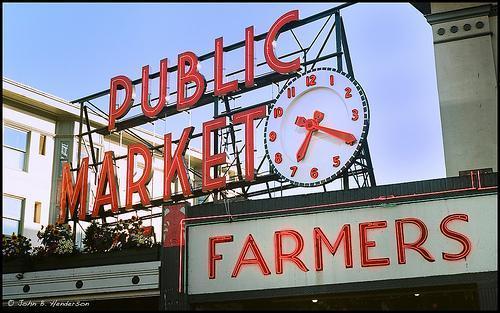How many clocks are in the photo?
Give a very brief answer. 1. 